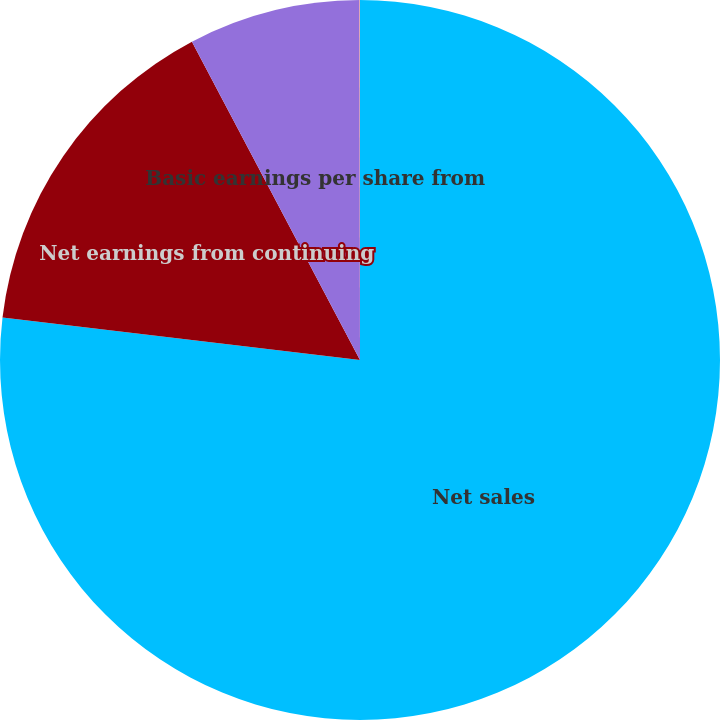<chart> <loc_0><loc_0><loc_500><loc_500><pie_chart><fcel>Net sales<fcel>Net earnings from continuing<fcel>Basic earnings per share from<fcel>Diluted earnings per share<nl><fcel>76.88%<fcel>15.39%<fcel>7.71%<fcel>0.02%<nl></chart> 